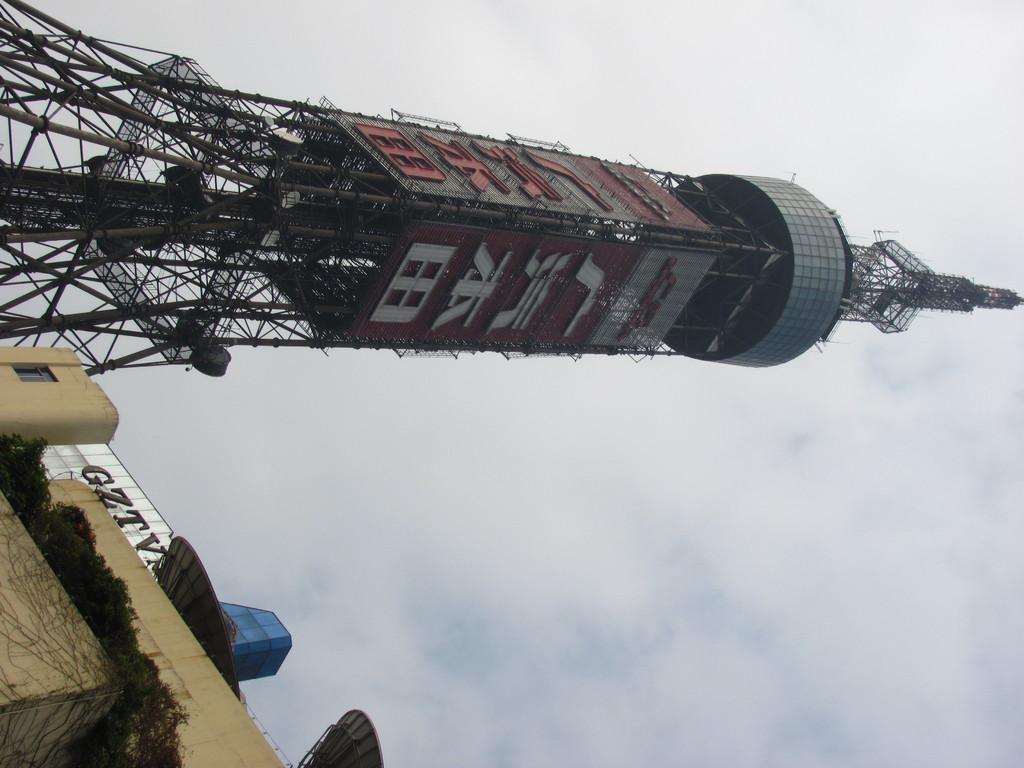Could you give a brief overview of what you see in this image? In this image I can see building, clouds, the sky, a tower and I can see something is written at few places. 